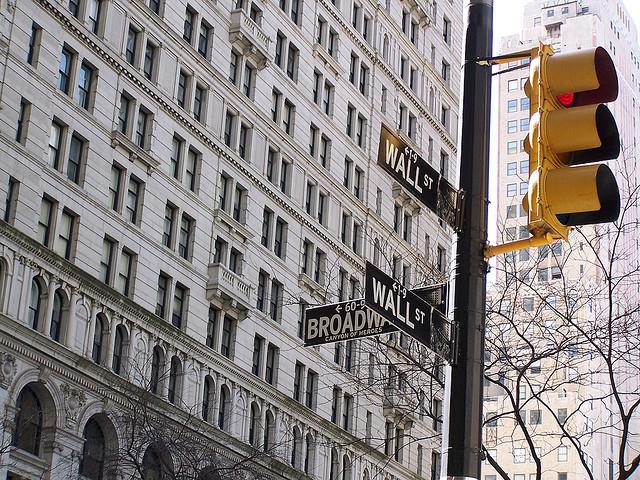How many windows can you see?
Be succinct. 100. What is one of the streets called?
Be succinct. Wall. Do the trees have leaves?
Keep it brief. No. How many traffic lights are visible?
Concise answer only. 1. What color is the light?
Write a very short answer. Red. What color is the traffic light?
Short answer required. Red. Is the green signal light on?
Quick response, please. No. How many stories is the building on the left?
Short answer required. 12. 